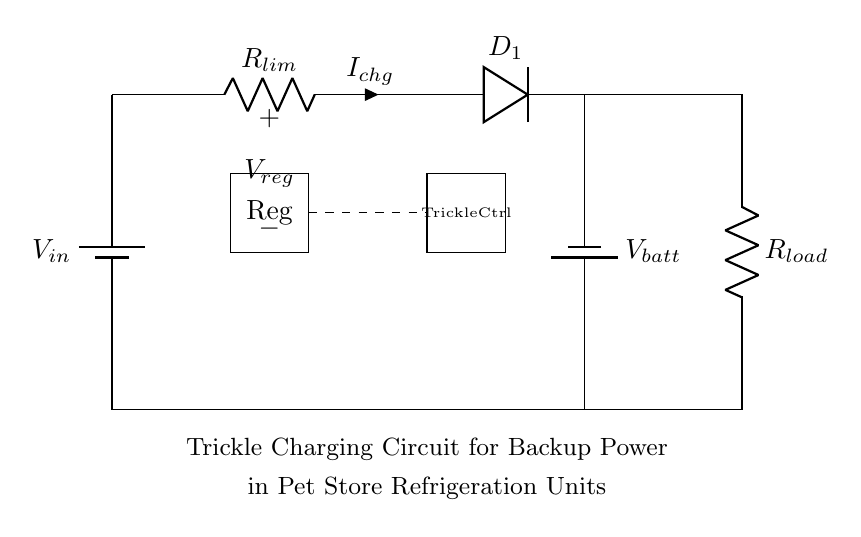What is the charging current in the circuit? The current charging the battery is indicated as I_chg, which is the current flowing through the resistor labeled R_lim.
Answer: I_chg What type of diode is used in this circuit? The circuit includes a diode labeled D_1, which typically functions as a rectifier in charging applications.
Answer: Rectifier What component controls the trickle charging? The trickle charging is managed by a component labeled Trickle Ctrl in the circuit, which regulates the charging current to avoid overcharging.
Answer: Trickle Ctrl What is the purpose of the resistance labeled R_lim? The resistor R_lim limits the charging current flowing into the battery, ensuring that it does not exceed safe levels for charging.
Answer: Current limitation How many batteries are shown in the circuit? The diagram depicts two batteries: one for the input supply (labeled V_in) and another being charged (labeled V_batt).
Answer: Two What is the role of the voltage regulator? The voltage regulator, labeled V_reg, stabilizes the output voltage to a specific level, ensuring that the battery receives a consistent voltage during charging.
Answer: Stabilizes voltage 